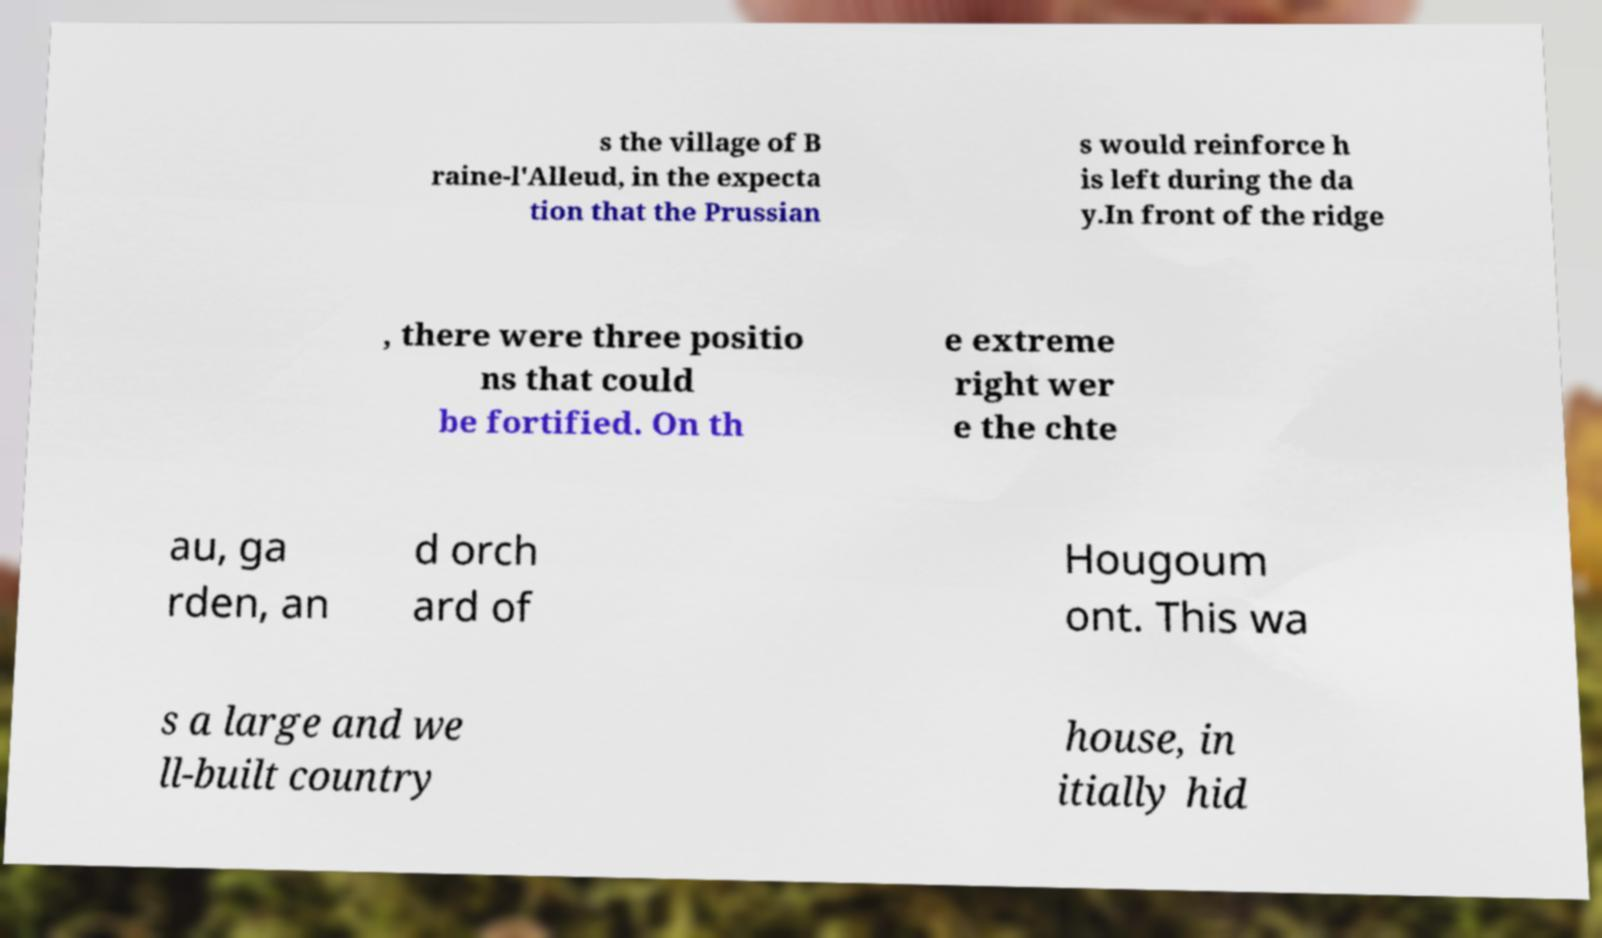Please identify and transcribe the text found in this image. s the village of B raine-l'Alleud, in the expecta tion that the Prussian s would reinforce h is left during the da y.In front of the ridge , there were three positio ns that could be fortified. On th e extreme right wer e the chte au, ga rden, an d orch ard of Hougoum ont. This wa s a large and we ll-built country house, in itially hid 